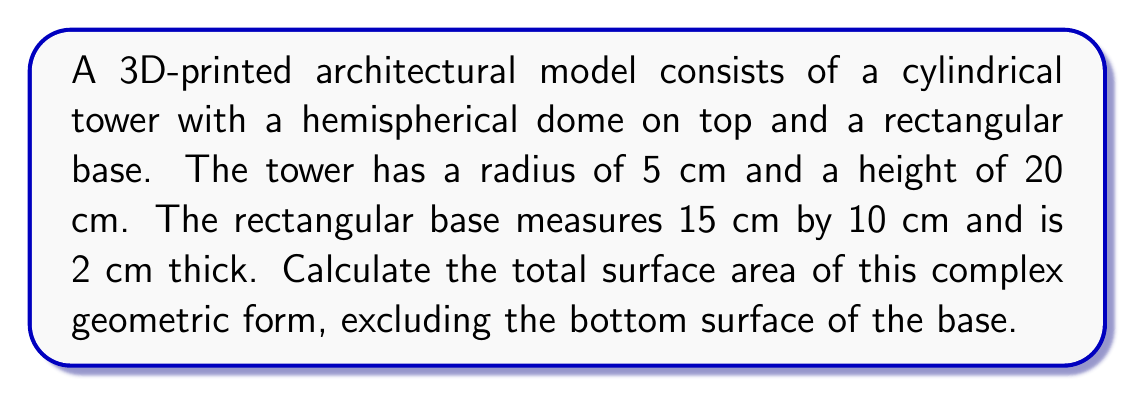Help me with this question. Let's break this down step-by-step:

1. Surface area of the cylindrical tower:
   - Lateral surface area: $A_{lateral} = 2\pi rh$
   - $A_{lateral} = 2\pi \cdot 5 \cdot 20 = 200\pi$ cm²
   - Top circular area: $A_{top} = \pi r^2 = \pi \cdot 5^2 = 25\pi$ cm²
   - Total cylinder surface area: $A_{cylinder} = 200\pi + 25\pi = 225\pi$ cm²

2. Surface area of the hemispherical dome:
   - $A_{dome} = 2\pi r^2 = 2\pi \cdot 5^2 = 50\pi$ cm²

3. Surface area of the rectangular base:
   - Top: $A_{top} = 15 \cdot 10 = 150$ cm²
   - Sides: $A_{sides} = 2(15 \cdot 2 + 10 \cdot 2) = 100$ cm²
   - Total base surface area (excluding bottom): $A_{base} = 150 + 100 = 250$ cm²

4. Total surface area:
   $A_{total} = A_{cylinder} + A_{dome} + A_{base}$
   $A_{total} = 225\pi + 50\pi + 250$
   $A_{total} = 275\pi + 250$ cm²

Simplifying:
$A_{total} = 275\pi + 250 \approx 1113.71$ cm²
Answer: $275\pi + 250$ cm² or approximately 1113.71 cm² 